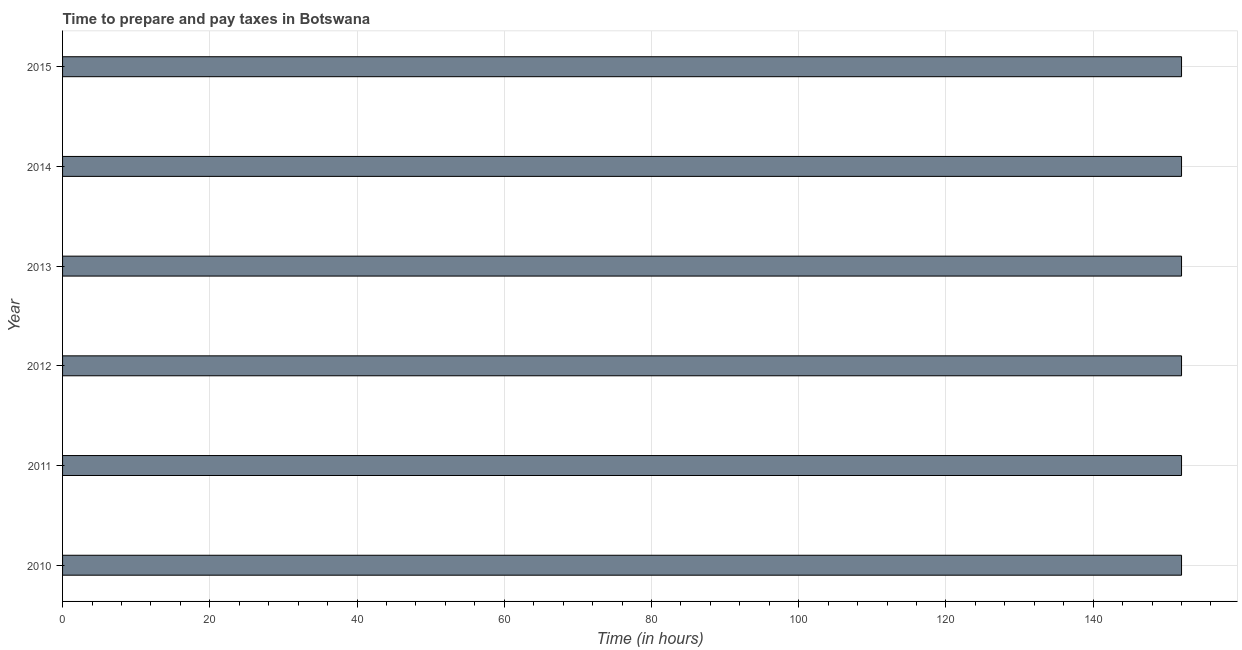Does the graph contain grids?
Offer a terse response. Yes. What is the title of the graph?
Ensure brevity in your answer.  Time to prepare and pay taxes in Botswana. What is the label or title of the X-axis?
Make the answer very short. Time (in hours). What is the label or title of the Y-axis?
Your answer should be very brief. Year. What is the time to prepare and pay taxes in 2014?
Keep it short and to the point. 152. Across all years, what is the maximum time to prepare and pay taxes?
Your response must be concise. 152. Across all years, what is the minimum time to prepare and pay taxes?
Give a very brief answer. 152. In which year was the time to prepare and pay taxes minimum?
Your answer should be very brief. 2010. What is the sum of the time to prepare and pay taxes?
Keep it short and to the point. 912. What is the average time to prepare and pay taxes per year?
Provide a short and direct response. 152. What is the median time to prepare and pay taxes?
Give a very brief answer. 152. Is the difference between the time to prepare and pay taxes in 2013 and 2014 greater than the difference between any two years?
Provide a succinct answer. Yes. Is the sum of the time to prepare and pay taxes in 2012 and 2015 greater than the maximum time to prepare and pay taxes across all years?
Ensure brevity in your answer.  Yes. In how many years, is the time to prepare and pay taxes greater than the average time to prepare and pay taxes taken over all years?
Your response must be concise. 0. Are all the bars in the graph horizontal?
Offer a very short reply. Yes. How many years are there in the graph?
Make the answer very short. 6. What is the difference between two consecutive major ticks on the X-axis?
Give a very brief answer. 20. What is the Time (in hours) of 2010?
Your answer should be compact. 152. What is the Time (in hours) in 2011?
Ensure brevity in your answer.  152. What is the Time (in hours) in 2012?
Keep it short and to the point. 152. What is the Time (in hours) in 2013?
Your answer should be very brief. 152. What is the Time (in hours) in 2014?
Provide a succinct answer. 152. What is the Time (in hours) in 2015?
Offer a very short reply. 152. What is the difference between the Time (in hours) in 2010 and 2011?
Give a very brief answer. 0. What is the difference between the Time (in hours) in 2010 and 2014?
Provide a short and direct response. 0. What is the difference between the Time (in hours) in 2010 and 2015?
Your answer should be compact. 0. What is the difference between the Time (in hours) in 2011 and 2012?
Offer a very short reply. 0. What is the difference between the Time (in hours) in 2011 and 2013?
Ensure brevity in your answer.  0. What is the difference between the Time (in hours) in 2011 and 2015?
Offer a terse response. 0. What is the difference between the Time (in hours) in 2012 and 2013?
Provide a short and direct response. 0. What is the difference between the Time (in hours) in 2013 and 2014?
Offer a terse response. 0. What is the difference between the Time (in hours) in 2013 and 2015?
Offer a very short reply. 0. What is the ratio of the Time (in hours) in 2010 to that in 2011?
Provide a succinct answer. 1. What is the ratio of the Time (in hours) in 2010 to that in 2012?
Offer a terse response. 1. What is the ratio of the Time (in hours) in 2010 to that in 2013?
Your response must be concise. 1. What is the ratio of the Time (in hours) in 2011 to that in 2012?
Make the answer very short. 1. What is the ratio of the Time (in hours) in 2011 to that in 2013?
Ensure brevity in your answer.  1. What is the ratio of the Time (in hours) in 2011 to that in 2014?
Provide a succinct answer. 1. What is the ratio of the Time (in hours) in 2012 to that in 2013?
Your answer should be very brief. 1. What is the ratio of the Time (in hours) in 2012 to that in 2014?
Ensure brevity in your answer.  1. What is the ratio of the Time (in hours) in 2012 to that in 2015?
Your response must be concise. 1. What is the ratio of the Time (in hours) in 2013 to that in 2014?
Give a very brief answer. 1. 